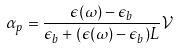Convert formula to latex. <formula><loc_0><loc_0><loc_500><loc_500>\alpha _ { p } = \frac { \epsilon ( \omega ) - \epsilon _ { b } } { \epsilon _ { b } + ( \epsilon ( \omega ) - \epsilon _ { b } ) L } \mathcal { V }</formula> 